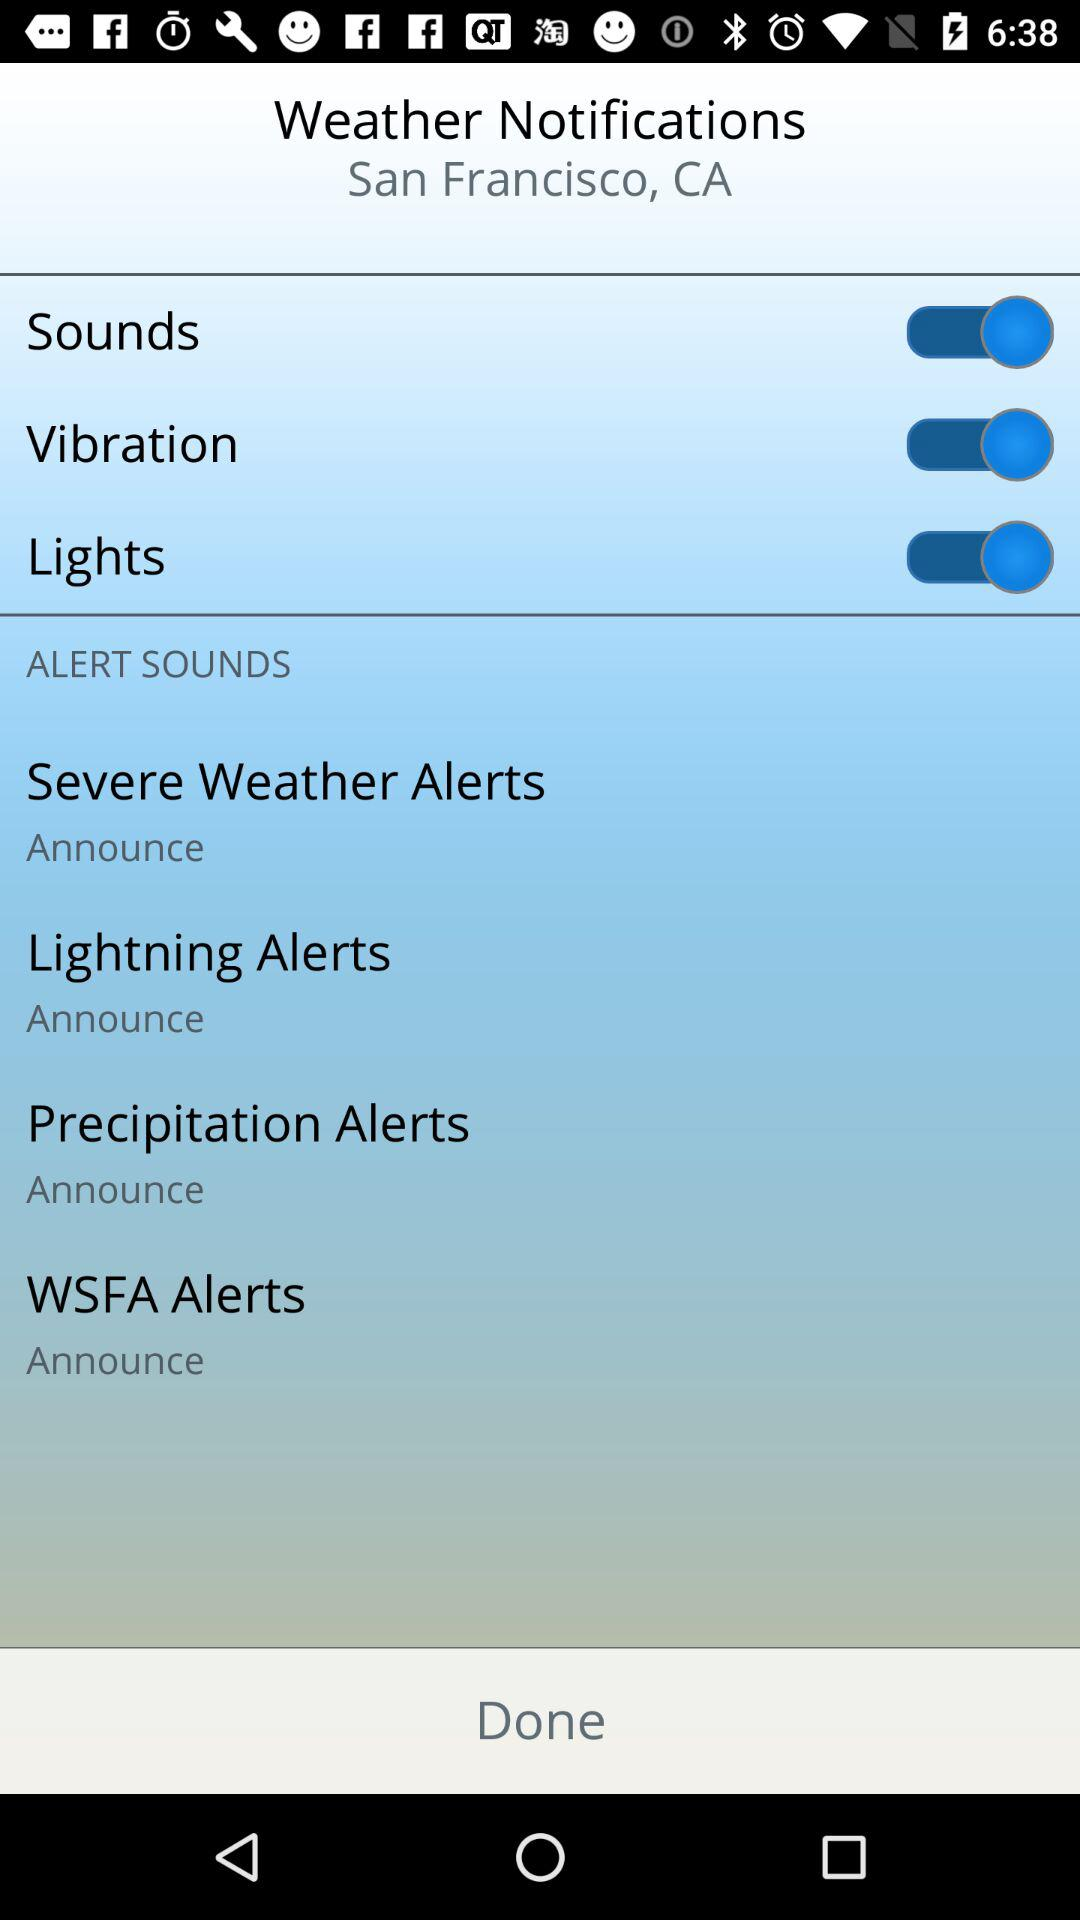Where is the setting for alert Sounds?
When the provided information is insufficient, respond with <no answer>. <no answer> 